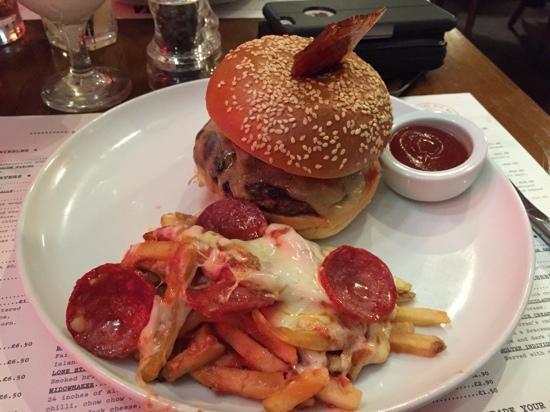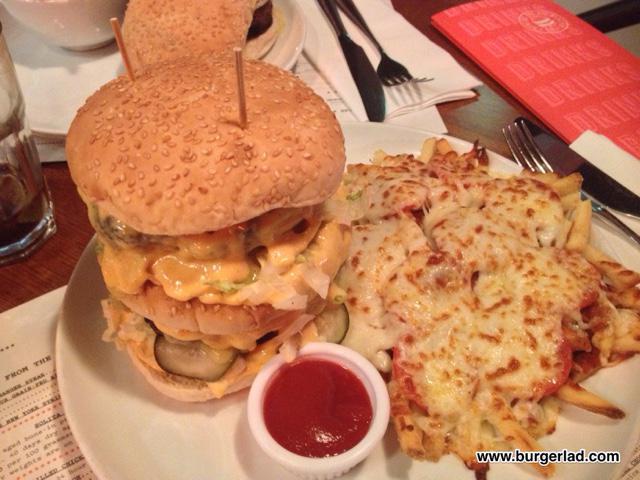The first image is the image on the left, the second image is the image on the right. Considering the images on both sides, is "At least one burger is shown on a plate with some pizza fries." valid? Answer yes or no. Yes. The first image is the image on the left, the second image is the image on the right. Evaluate the accuracy of this statement regarding the images: "In at least one image there is a white plate with pizza fries and a burger next to ketchup.". Is it true? Answer yes or no. Yes. 